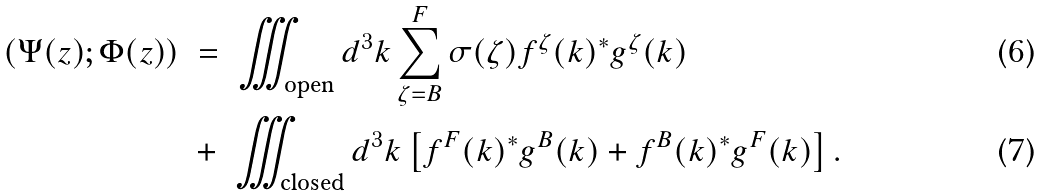Convert formula to latex. <formula><loc_0><loc_0><loc_500><loc_500>( \Psi ( z ) ; \Phi ( z ) ) \ & = \ \iiint _ { \text {open} } d ^ { 3 } k \sum _ { \zeta = B } ^ { F } \sigma ( \zeta ) f ^ { \zeta } ( k ) ^ { \ast } g ^ { \zeta } ( k ) \\ & + \ \iiint _ { \text {closed} } d ^ { 3 } k \left [ f ^ { F } ( k ) ^ { \ast } g ^ { B } ( k ) + f ^ { B } ( k ) ^ { \ast } g ^ { F } ( k ) \right ] .</formula> 